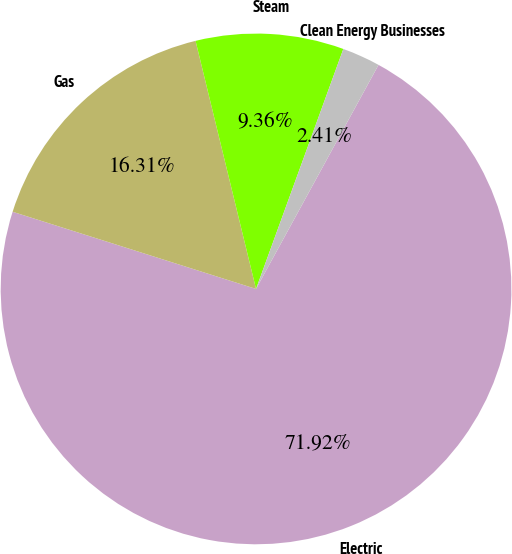Convert chart. <chart><loc_0><loc_0><loc_500><loc_500><pie_chart><fcel>Electric<fcel>Gas<fcel>Steam<fcel>Clean Energy Businesses<nl><fcel>71.93%<fcel>16.31%<fcel>9.36%<fcel>2.41%<nl></chart> 